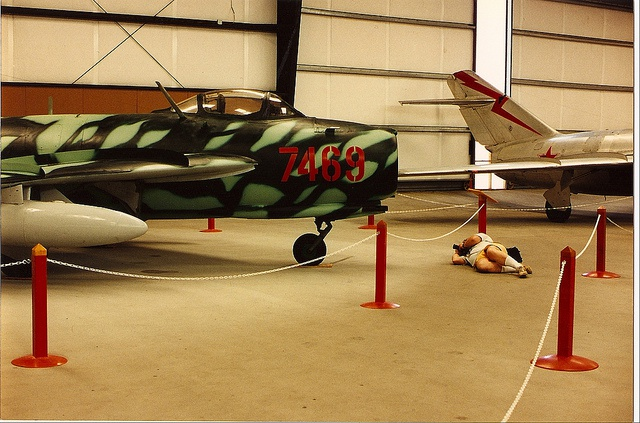Describe the objects in this image and their specific colors. I can see airplane in lightgray, black, olive, tan, and maroon tones, airplane in lightgray, black, olive, and maroon tones, people in lightgray, tan, brown, maroon, and khaki tones, and handbag in lightgray, black, gray, and tan tones in this image. 